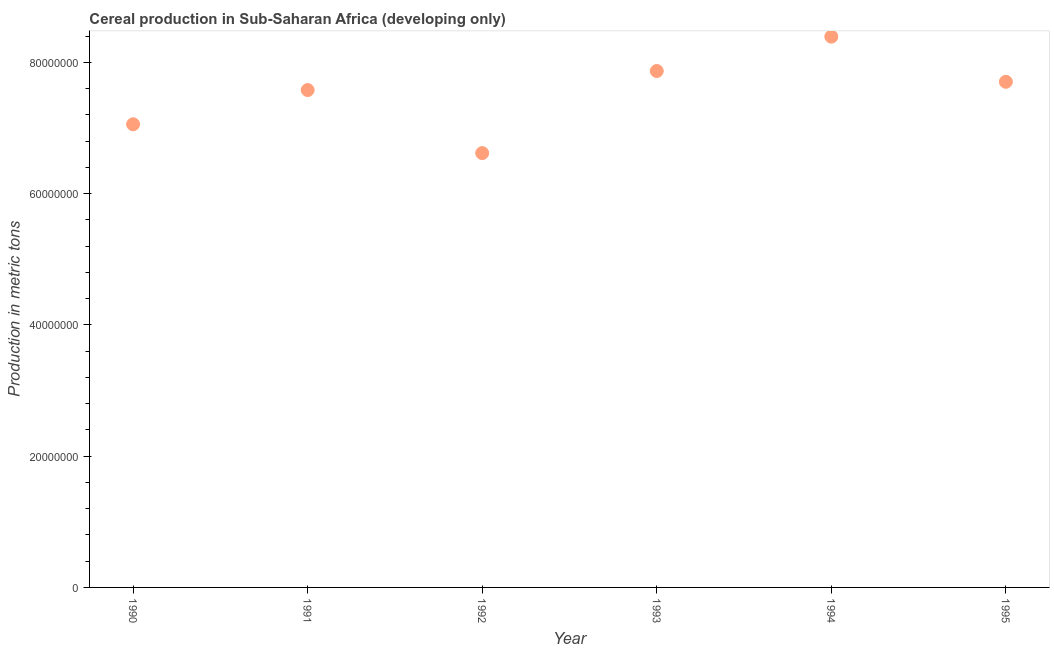What is the cereal production in 1992?
Provide a short and direct response. 6.62e+07. Across all years, what is the maximum cereal production?
Offer a very short reply. 8.39e+07. Across all years, what is the minimum cereal production?
Offer a very short reply. 6.62e+07. In which year was the cereal production maximum?
Provide a succinct answer. 1994. In which year was the cereal production minimum?
Provide a succinct answer. 1992. What is the sum of the cereal production?
Provide a short and direct response. 4.52e+08. What is the difference between the cereal production in 1990 and 1995?
Provide a short and direct response. -6.47e+06. What is the average cereal production per year?
Offer a terse response. 7.54e+07. What is the median cereal production?
Your answer should be compact. 7.64e+07. Do a majority of the years between 1991 and 1992 (inclusive) have cereal production greater than 64000000 metric tons?
Offer a very short reply. Yes. What is the ratio of the cereal production in 1992 to that in 1995?
Your answer should be compact. 0.86. Is the difference between the cereal production in 1990 and 1994 greater than the difference between any two years?
Your answer should be compact. No. What is the difference between the highest and the second highest cereal production?
Make the answer very short. 5.23e+06. Is the sum of the cereal production in 1993 and 1995 greater than the maximum cereal production across all years?
Give a very brief answer. Yes. What is the difference between the highest and the lowest cereal production?
Provide a succinct answer. 1.77e+07. How many dotlines are there?
Offer a terse response. 1. What is the difference between two consecutive major ticks on the Y-axis?
Offer a terse response. 2.00e+07. Are the values on the major ticks of Y-axis written in scientific E-notation?
Your response must be concise. No. Does the graph contain any zero values?
Keep it short and to the point. No. Does the graph contain grids?
Your answer should be very brief. No. What is the title of the graph?
Provide a succinct answer. Cereal production in Sub-Saharan Africa (developing only). What is the label or title of the Y-axis?
Your answer should be compact. Production in metric tons. What is the Production in metric tons in 1990?
Offer a terse response. 7.06e+07. What is the Production in metric tons in 1991?
Your answer should be very brief. 7.58e+07. What is the Production in metric tons in 1992?
Your answer should be very brief. 6.62e+07. What is the Production in metric tons in 1993?
Give a very brief answer. 7.87e+07. What is the Production in metric tons in 1994?
Offer a terse response. 8.39e+07. What is the Production in metric tons in 1995?
Offer a terse response. 7.70e+07. What is the difference between the Production in metric tons in 1990 and 1991?
Offer a very short reply. -5.21e+06. What is the difference between the Production in metric tons in 1990 and 1992?
Ensure brevity in your answer.  4.39e+06. What is the difference between the Production in metric tons in 1990 and 1993?
Your response must be concise. -8.12e+06. What is the difference between the Production in metric tons in 1990 and 1994?
Keep it short and to the point. -1.34e+07. What is the difference between the Production in metric tons in 1990 and 1995?
Ensure brevity in your answer.  -6.47e+06. What is the difference between the Production in metric tons in 1991 and 1992?
Your response must be concise. 9.61e+06. What is the difference between the Production in metric tons in 1991 and 1993?
Ensure brevity in your answer.  -2.90e+06. What is the difference between the Production in metric tons in 1991 and 1994?
Provide a short and direct response. -8.14e+06. What is the difference between the Production in metric tons in 1991 and 1995?
Your answer should be compact. -1.26e+06. What is the difference between the Production in metric tons in 1992 and 1993?
Your answer should be very brief. -1.25e+07. What is the difference between the Production in metric tons in 1992 and 1994?
Ensure brevity in your answer.  -1.77e+07. What is the difference between the Production in metric tons in 1992 and 1995?
Your answer should be compact. -1.09e+07. What is the difference between the Production in metric tons in 1993 and 1994?
Keep it short and to the point. -5.23e+06. What is the difference between the Production in metric tons in 1993 and 1995?
Provide a short and direct response. 1.64e+06. What is the difference between the Production in metric tons in 1994 and 1995?
Your answer should be very brief. 6.88e+06. What is the ratio of the Production in metric tons in 1990 to that in 1992?
Offer a very short reply. 1.07. What is the ratio of the Production in metric tons in 1990 to that in 1993?
Keep it short and to the point. 0.9. What is the ratio of the Production in metric tons in 1990 to that in 1994?
Keep it short and to the point. 0.84. What is the ratio of the Production in metric tons in 1990 to that in 1995?
Give a very brief answer. 0.92. What is the ratio of the Production in metric tons in 1991 to that in 1992?
Keep it short and to the point. 1.15. What is the ratio of the Production in metric tons in 1991 to that in 1994?
Offer a very short reply. 0.9. What is the ratio of the Production in metric tons in 1991 to that in 1995?
Ensure brevity in your answer.  0.98. What is the ratio of the Production in metric tons in 1992 to that in 1993?
Give a very brief answer. 0.84. What is the ratio of the Production in metric tons in 1992 to that in 1994?
Offer a very short reply. 0.79. What is the ratio of the Production in metric tons in 1992 to that in 1995?
Ensure brevity in your answer.  0.86. What is the ratio of the Production in metric tons in 1993 to that in 1994?
Provide a succinct answer. 0.94. What is the ratio of the Production in metric tons in 1993 to that in 1995?
Provide a succinct answer. 1.02. What is the ratio of the Production in metric tons in 1994 to that in 1995?
Give a very brief answer. 1.09. 